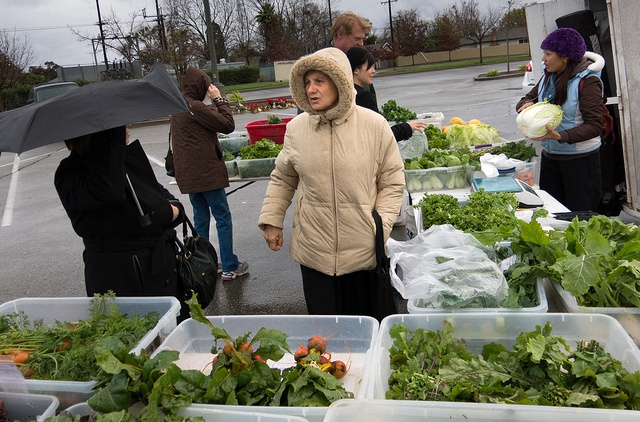Describe the objects in this image and their specific colors. I can see people in lightgray, tan, black, and gray tones, people in lightgray, black, darkgray, gray, and darkgreen tones, people in lightgray, black, gray, darkgray, and ivory tones, people in lightgray, black, navy, and darkgray tones, and umbrella in lightgray, black, and gray tones in this image. 